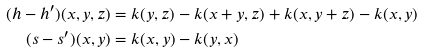Convert formula to latex. <formula><loc_0><loc_0><loc_500><loc_500>( h - h ^ { \prime } ) ( x , y , z ) & = k ( y , z ) - k ( x + y , z ) + k ( x , y + z ) - k ( x , y ) \\ ( s - s ^ { \prime } ) ( x , y ) & = k ( x , y ) - k ( y , x )</formula> 